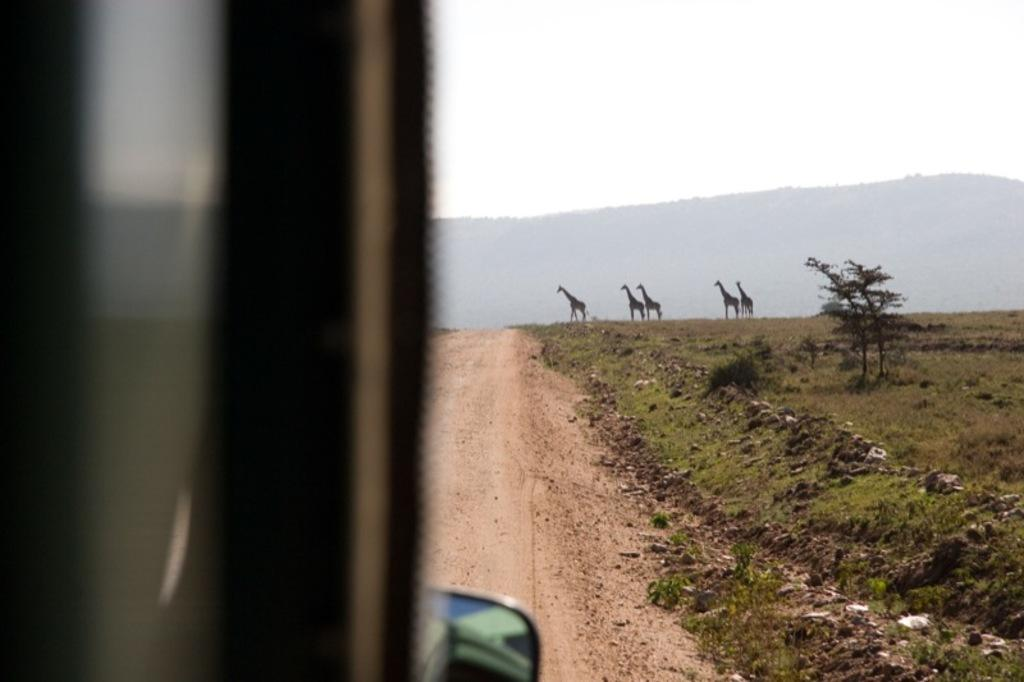What type of vegetation can be seen in the image? There is grass and plants in the image. What is visible on the ground in the image? The ground is visible in the image. What animals are present in the image? There are giraffes in the image. What can be seen in the background of the image? There is a mountain and the sky visible in the background of the image. Can you describe the vehicle in the image? There is a vehicle on the left side of the image, but it is truncated. What is the topic of the argument taking place in the image? There is no argument present in the image. Can you tell me how many baseballs are visible in the image? There are no baseballs present in the image. 